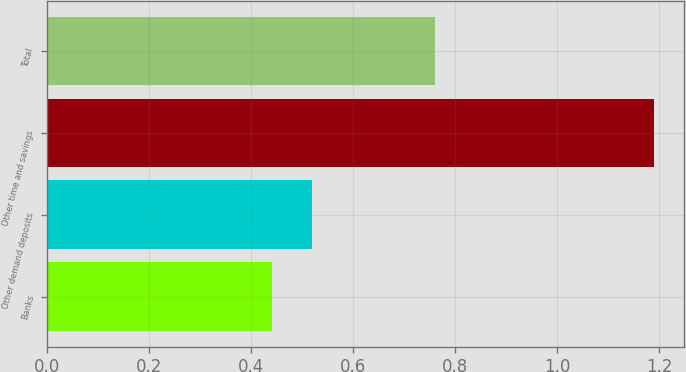Convert chart. <chart><loc_0><loc_0><loc_500><loc_500><bar_chart><fcel>Banks<fcel>Other demand deposits<fcel>Other time and savings<fcel>Total<nl><fcel>0.44<fcel>0.52<fcel>1.19<fcel>0.76<nl></chart> 